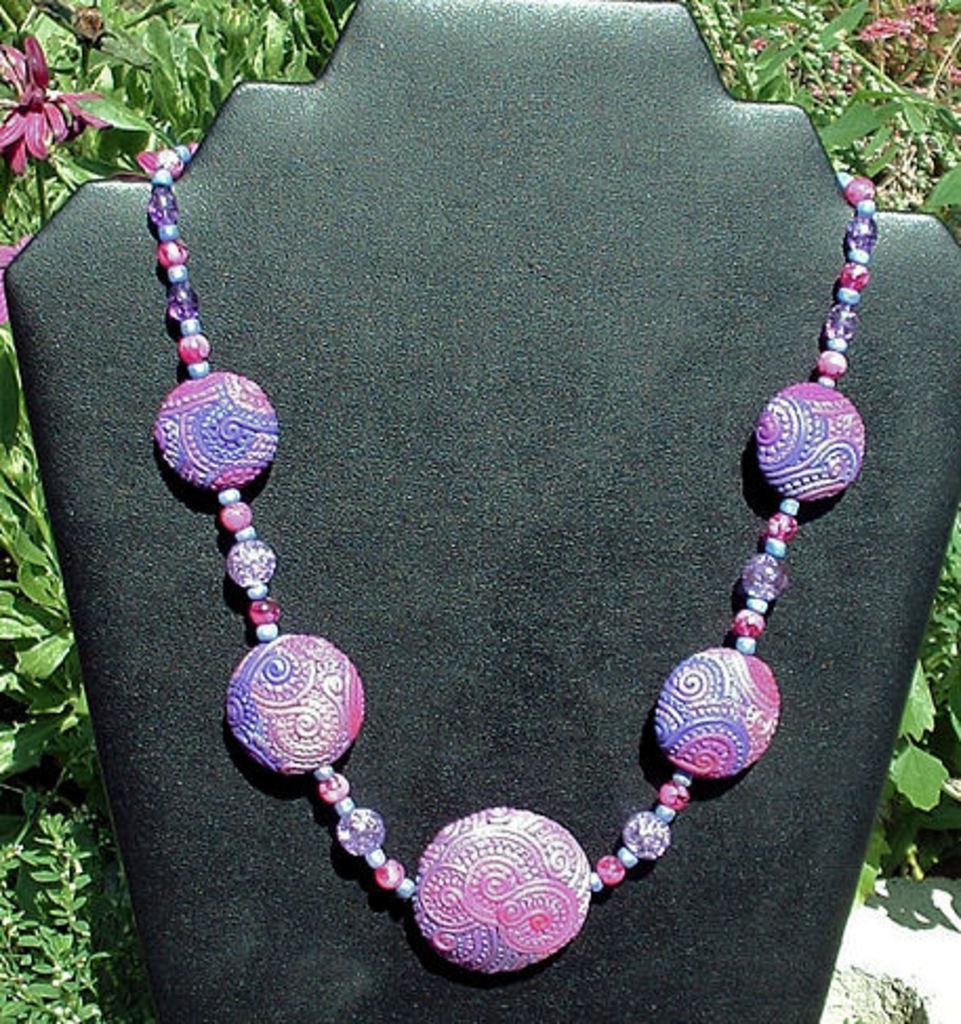In one or two sentences, can you explain what this image depicts? this picture shows an ornament and back of it we can see some plants 